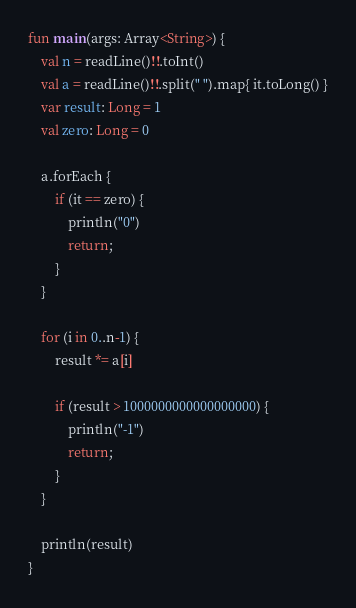Convert code to text. <code><loc_0><loc_0><loc_500><loc_500><_Kotlin_>fun main(args: Array<String>) {
	val n = readLine()!!.toInt()
  	val a = readLine()!!.split(" ").map{ it.toLong() }
  	var result: Long = 1
  	val zero: Long = 0
  	
  	a.forEach {
    	if (it == zero) {
         	println("0")
          	return;
        }
    }

  	for (i in 0..n-1) {
    	result *= a[i]	
     	
      	if (result > 1000000000000000000) {
  			println("-1")
          	return;
  		}
    }
    
 	println(result)  
}</code> 